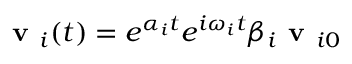<formula> <loc_0><loc_0><loc_500><loc_500>v _ { i } ( t ) = e ^ { \alpha _ { i } t } e ^ { i \omega _ { i } t } \beta _ { i } v _ { i 0 }</formula> 